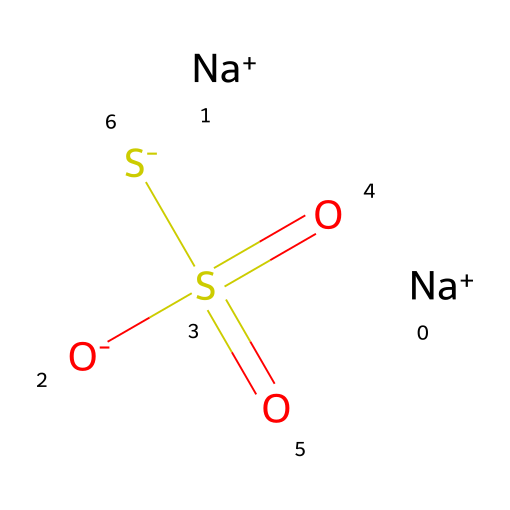What is the molecular formula of sodium thiosulfate? The molecular formula can be derived from the SMILES representation by identifying the components present. The formula indicates two sodium atoms, one sulfur atom bonded to two oxygen atoms (as part of the thiosulfate ion), and one additional sulfur atom. Therefore, the molecular formula is Na2S2O3.
Answer: Na2S2O3 How many oxygen atoms are in sodium thiosulfate? From the molecular formula Na2S2O3, we can see there are three oxygen atoms present in the structure.
Answer: 3 What type of ion is represented by [Na+] in sodium thiosulfate? The notation [Na+] indicates a sodium cation, which is a positively charged ion formed when sodium loses an electron. This is a characteristic of alkali metal ions.
Answer: cation Which part of the structure is responsible for its role in photographic film processing? The thiosulfate ion (S2O3) in sodium thiosulfate is responsible for its function in photographic processing by helping to dissolve silver halides and stabilize the developed image.
Answer: thiosulfate ion How many sulfur atoms are present in sodium thiosulfate? By analyzing the molecular formula Na2S2O3, we can identify that there are two sulfur atoms in the structure noted as 'S2'.
Answer: 2 Why is sodium thiosulfate considered a reducing agent? Sodium thiosulfate is considered a reducing agent because it can donate electrons to other substances. In the context of photography, it helps reduce and stabilize the silver ions used in developing film.
Answer: reducing agent 